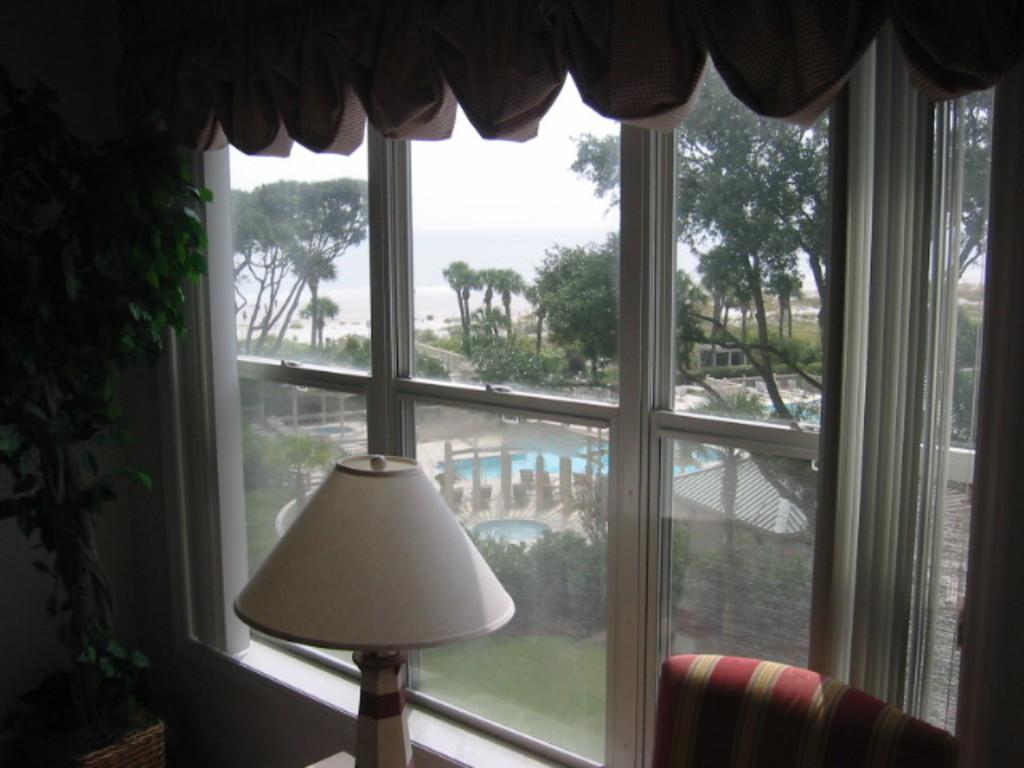Could you give a brief overview of what you see in this image? At the bottom of the picture, we see a chair and a lamp. On the left side, we see a plant pot. In the middle, we see the glass windows from which we can see the trees, grass, poles, railing, swimming pool and the sky. At the top, we see the curtains. 